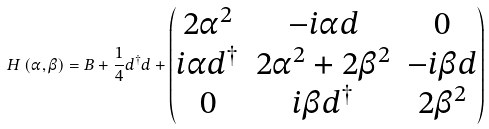Convert formula to latex. <formula><loc_0><loc_0><loc_500><loc_500>H \left ( \alpha , \beta \right ) = B + \frac { 1 } { 4 } d ^ { \dag } d + \begin{pmatrix} 2 \alpha ^ { 2 } & - i \alpha d & 0 \\ i \alpha d ^ { \dag } & 2 \alpha ^ { 2 } + 2 \beta ^ { 2 } & - i \beta d \\ 0 & i \beta d ^ { \dag } & 2 \beta ^ { 2 } \end{pmatrix}</formula> 